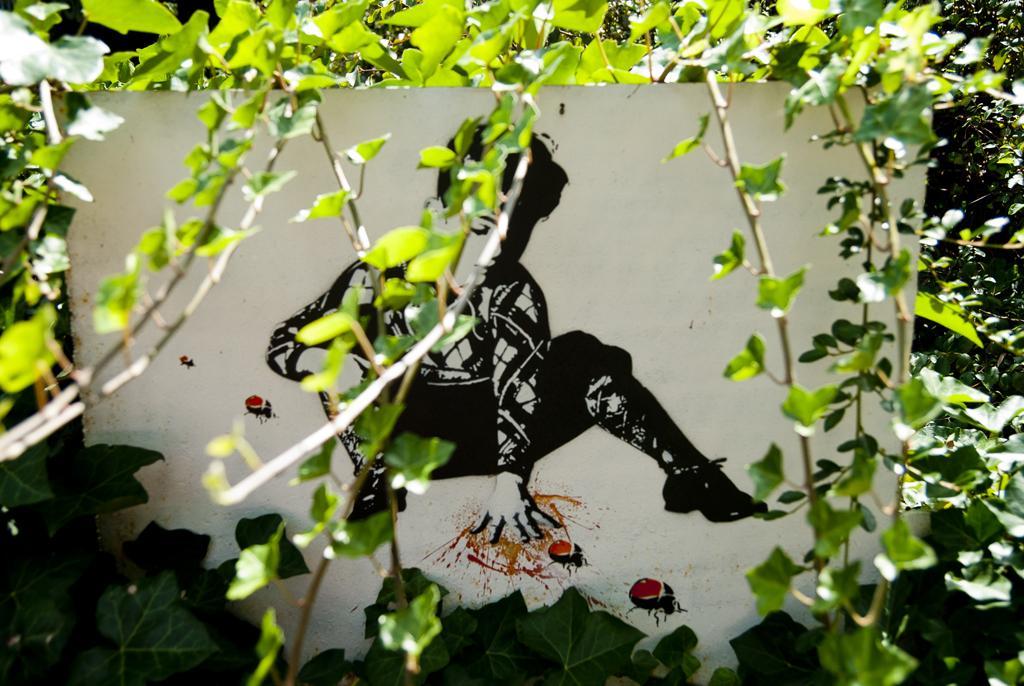How would you summarize this image in a sentence or two? In the image I can see a poster in which there is the picture of a boy and also I can see some stems to which there are some leaves. 